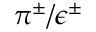Convert formula to latex. <formula><loc_0><loc_0><loc_500><loc_500>\pi ^ { \pm } / \epsilon ^ { \pm }</formula> 